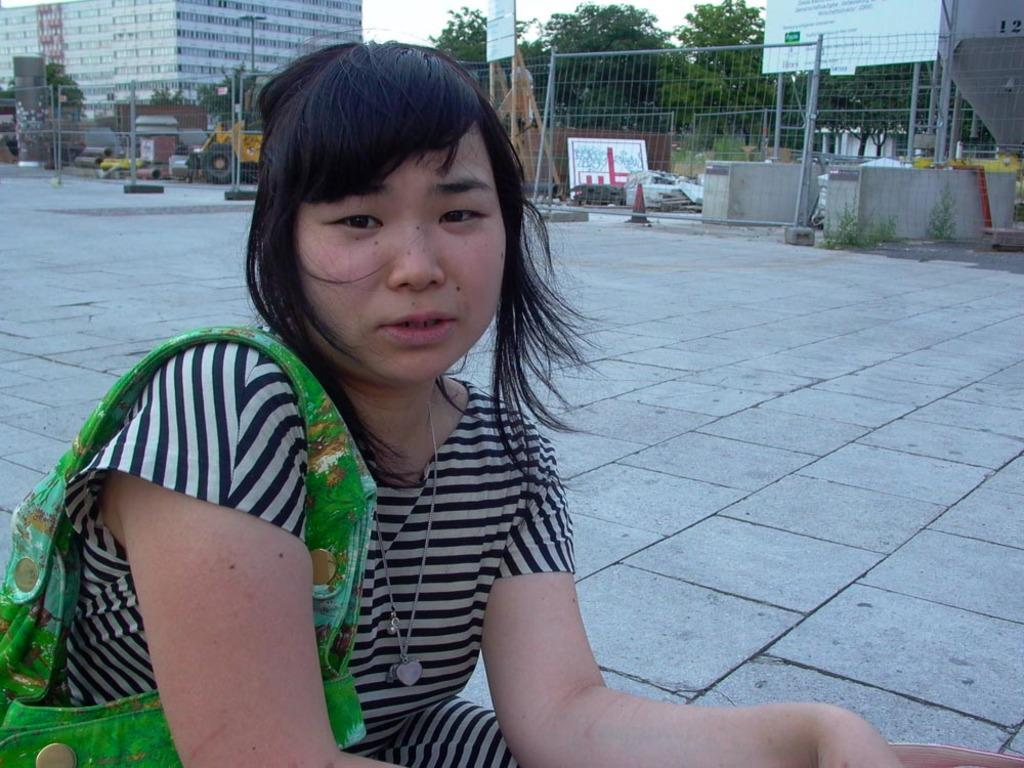Who is present in the image? There is a woman in the image. What is the woman wearing? The woman is wearing a bag. What type of surface is around the woman? There is a pavement around the woman. What can be seen behind the pavement? There is a building behind the pavement. What type of vegetation is visible in the image? There are trees visible in the image. What other objects can be seen in the image? There are other objects present in the image. How does the woman sleep while standing on the pavement? The woman is not sleeping in the image; she is standing with a bag. 